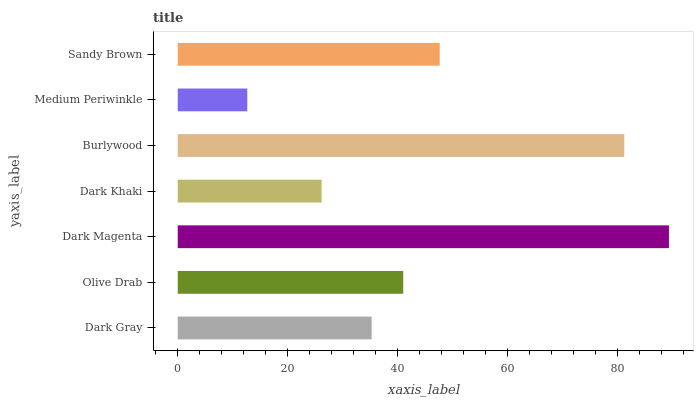Is Medium Periwinkle the minimum?
Answer yes or no. Yes. Is Dark Magenta the maximum?
Answer yes or no. Yes. Is Olive Drab the minimum?
Answer yes or no. No. Is Olive Drab the maximum?
Answer yes or no. No. Is Olive Drab greater than Dark Gray?
Answer yes or no. Yes. Is Dark Gray less than Olive Drab?
Answer yes or no. Yes. Is Dark Gray greater than Olive Drab?
Answer yes or no. No. Is Olive Drab less than Dark Gray?
Answer yes or no. No. Is Olive Drab the high median?
Answer yes or no. Yes. Is Olive Drab the low median?
Answer yes or no. Yes. Is Burlywood the high median?
Answer yes or no. No. Is Medium Periwinkle the low median?
Answer yes or no. No. 